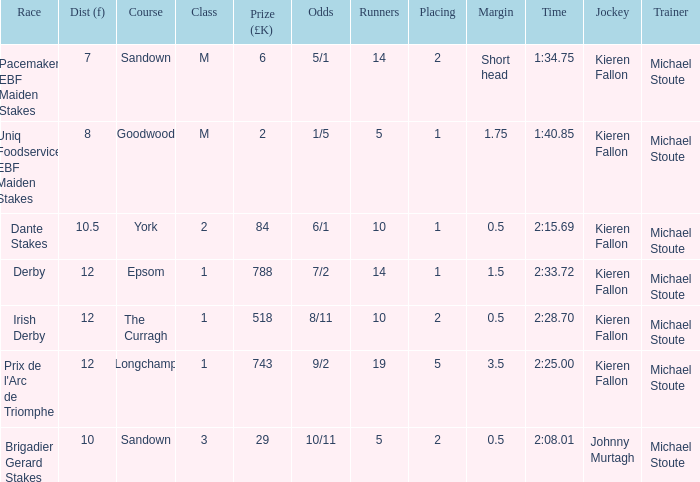List the competitors for longchamp. 19.0. 